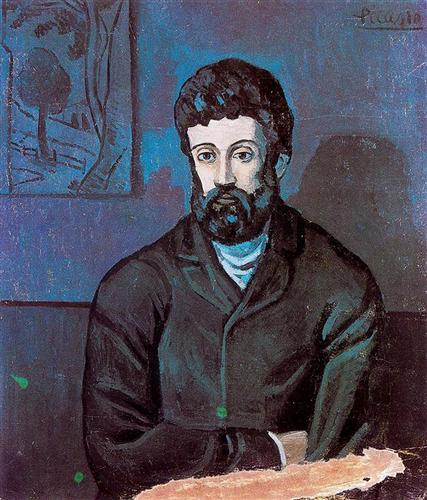If the sketched tree on the left could talk, what story might it tell? If the sketched tree on the left could talk, it might tell a tale intertwined with the man in the portrait. Perhaps it was a tree he once sat under during moments of contemplation or joy, its branches witnessing the passing of time and the changes in his life. The tree might speak of seasons past, the whisper of leaves in the breeze, and the passage of years, serving as a silent, steadfast observer to the man's journey. 